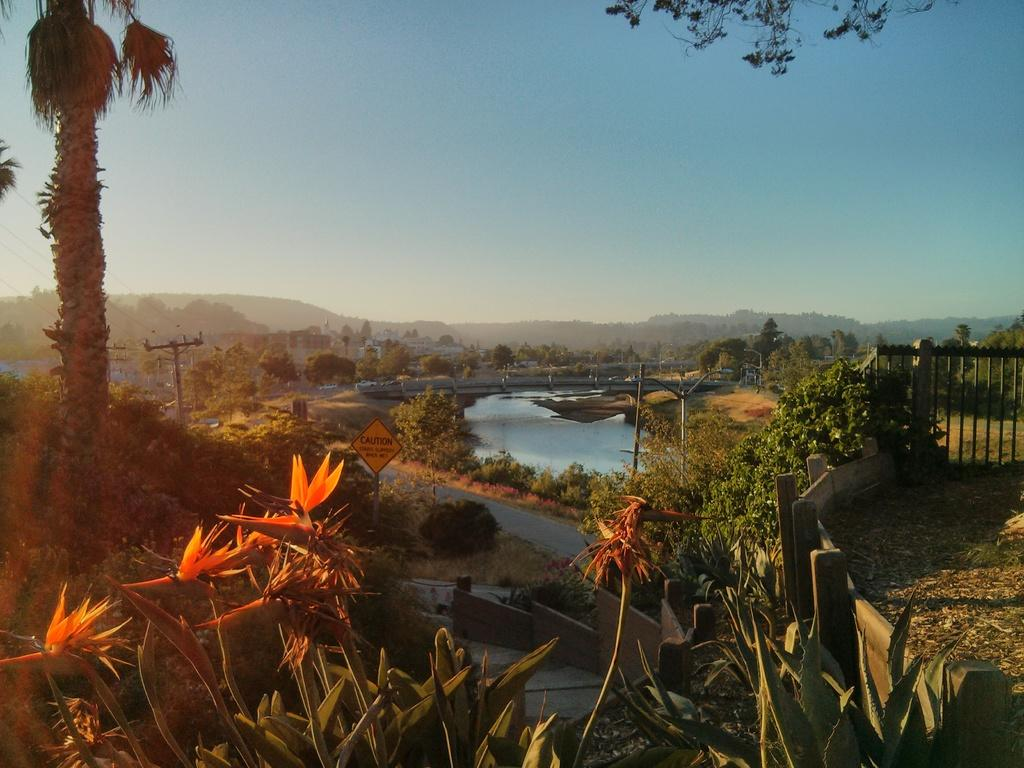What type of vegetation is present in the image? There are plants and trees in the image. What color are the plants and trees? The plants and trees are in green color. What can be seen in the background of the image? There is water and electric poles visible in the background of the image. What is the color of the sky in the image? The sky is blue and white in color. What type of quilt is being used to cover the trees in the image? There is no quilt present in the image; the trees are not covered by any fabric or material. What type of lumber is being used to construct the electric poles in the image? The image does not provide information about the type of lumber used to construct the electric poles. 